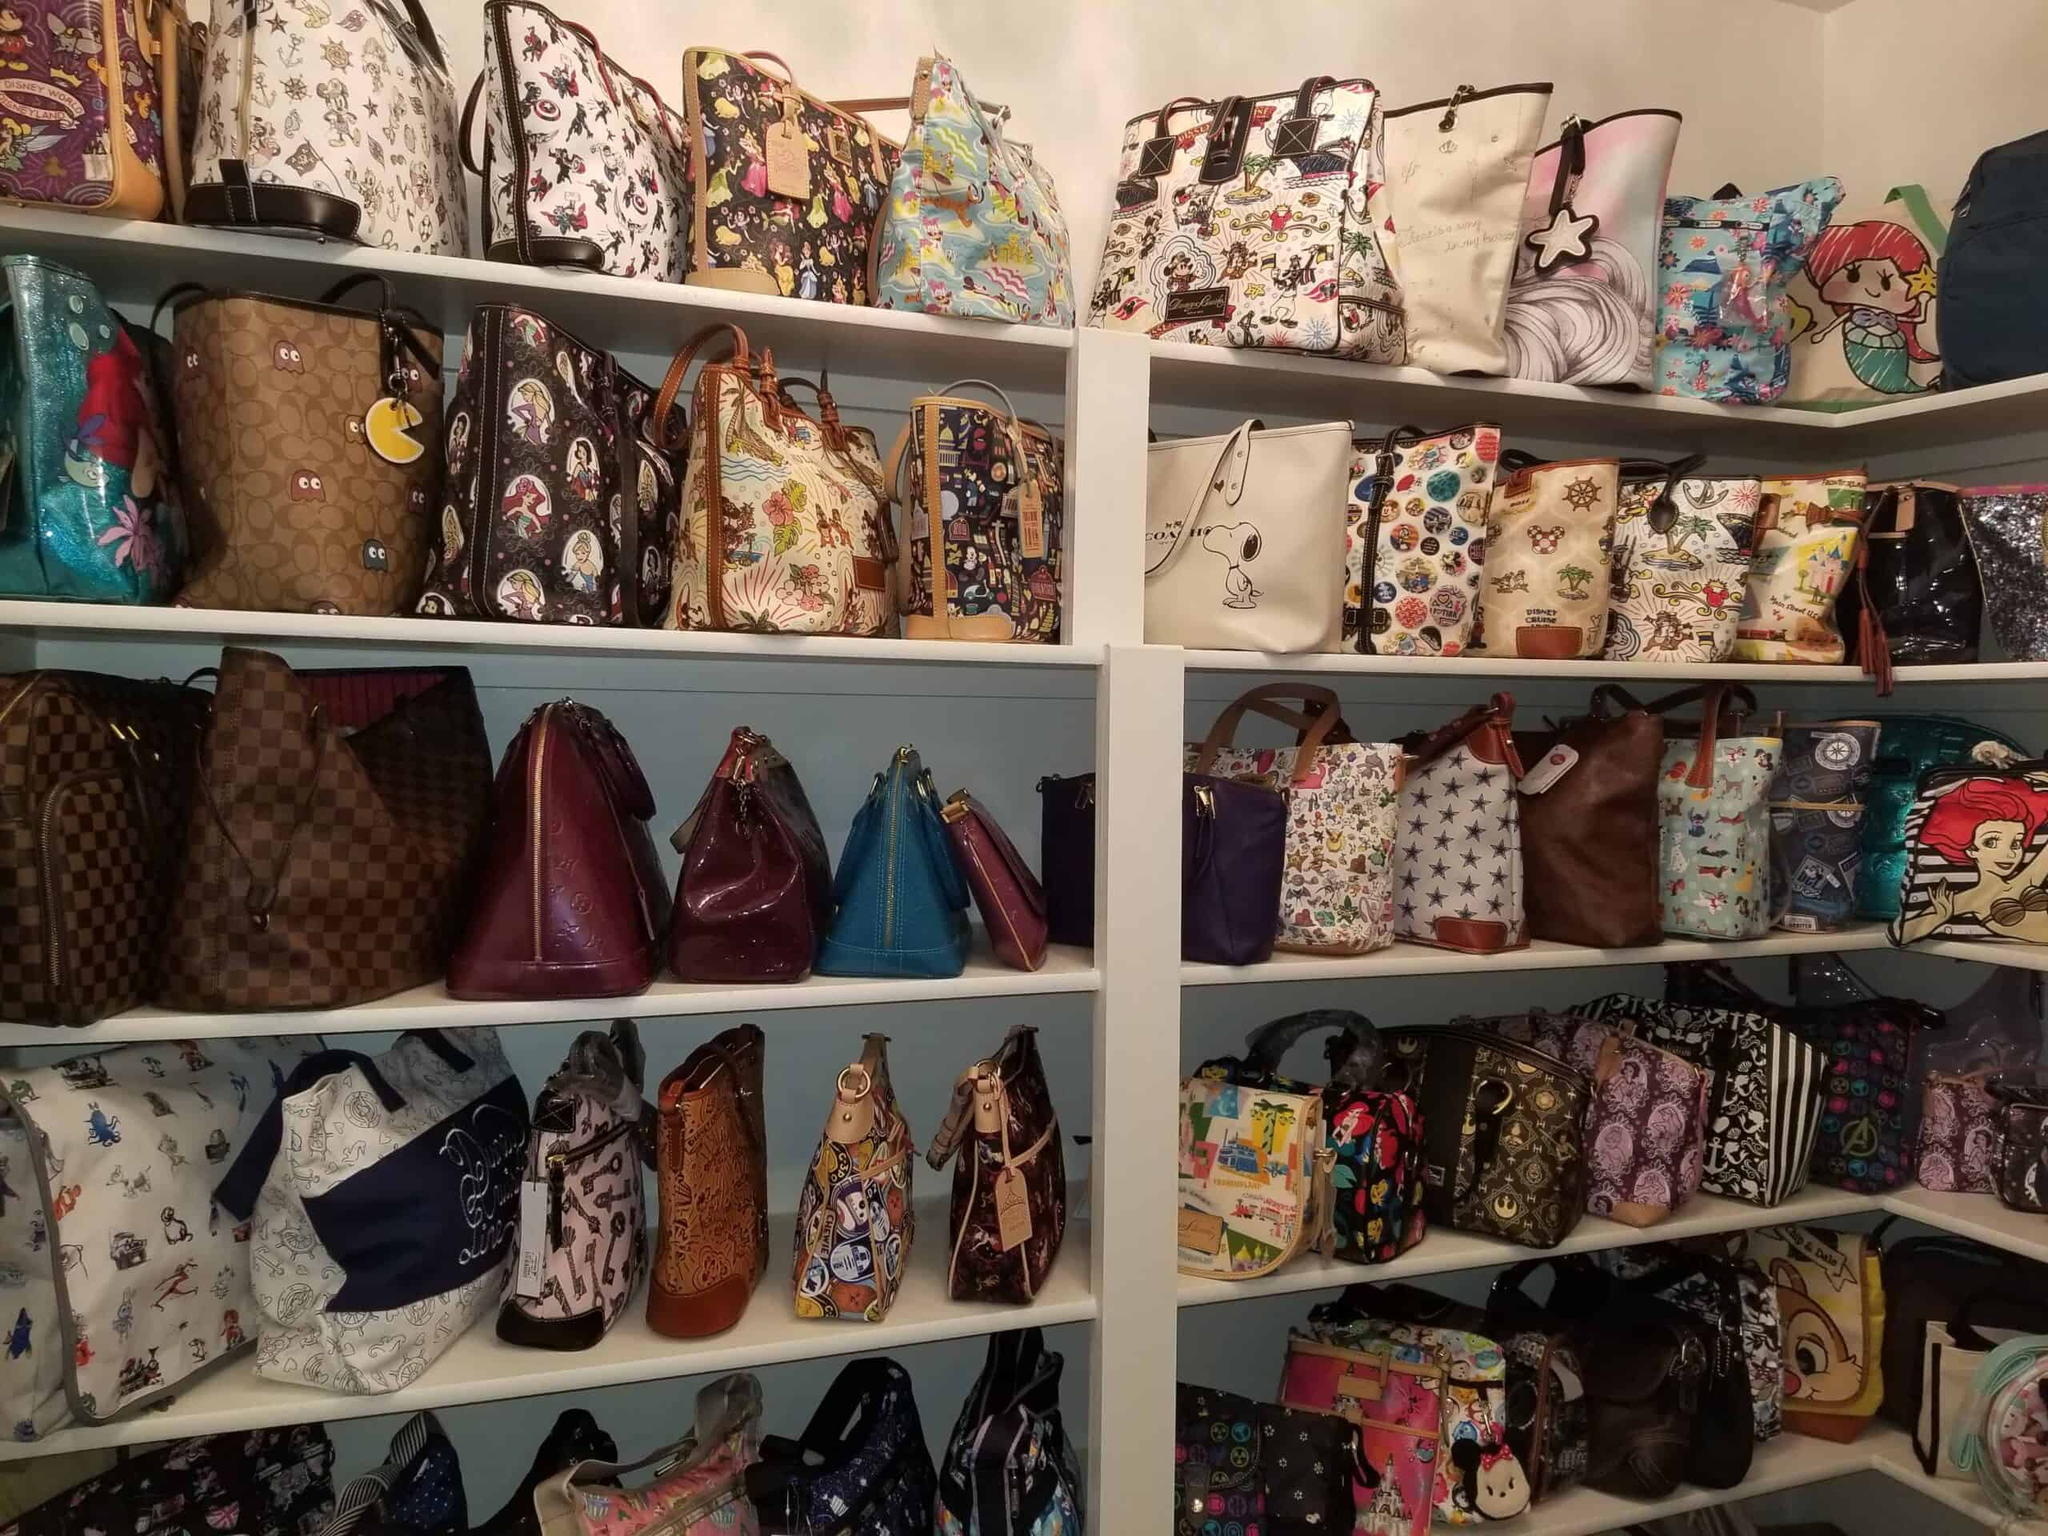How are the bags organized on the shelves? The bags are organized neatly on the shelves, with an upper section featuring bags with themed designs and cartoon characters, while the lower sections display a mix of patterned and solid-color bags. This arrangement helps to showcase the variety in styles and themes, creating a visually appealing display. 